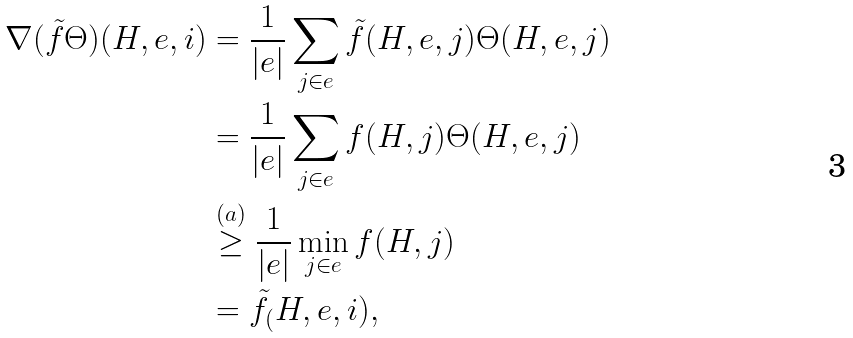Convert formula to latex. <formula><loc_0><loc_0><loc_500><loc_500>\nabla ( \tilde { f } \Theta ) ( H , e , i ) & = \frac { 1 } { | e | } \sum _ { j \in e } \tilde { f } ( H , e , j ) \Theta ( H , e , j ) \\ & = \frac { 1 } { | e | } \sum _ { j \in e } f ( H , j ) \Theta ( H , e , j ) \\ & \stackrel { ( a ) } { \geq } \frac { 1 } { | e | } \min _ { j \in e } f ( H , j ) \\ & = \tilde { f } _ { ( } H , e , i ) ,</formula> 